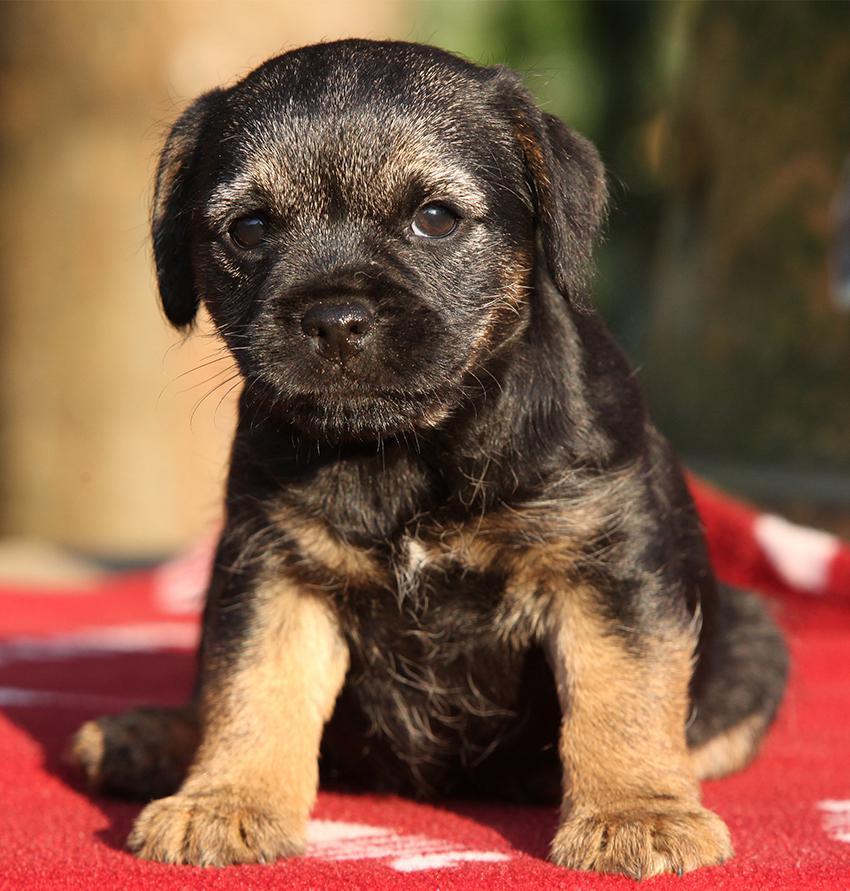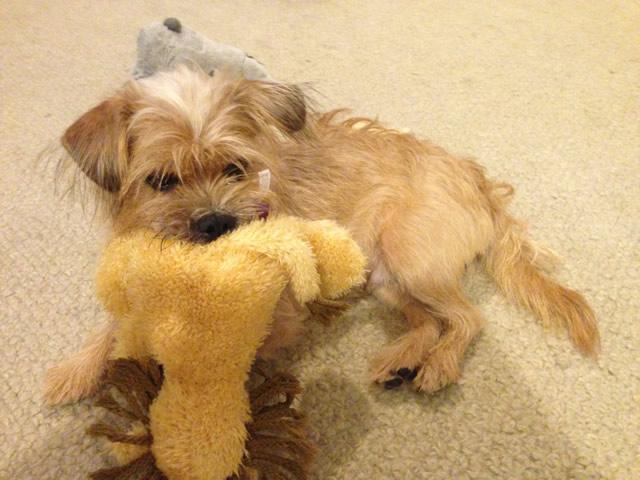The first image is the image on the left, the second image is the image on the right. Assess this claim about the two images: "A dog is on carpet in one picture and on a blanket in the other picture.". Correct or not? Answer yes or no. Yes. The first image is the image on the left, the second image is the image on the right. Analyze the images presented: Is the assertion "The dog in the right image has a green leash." valid? Answer yes or no. No. 